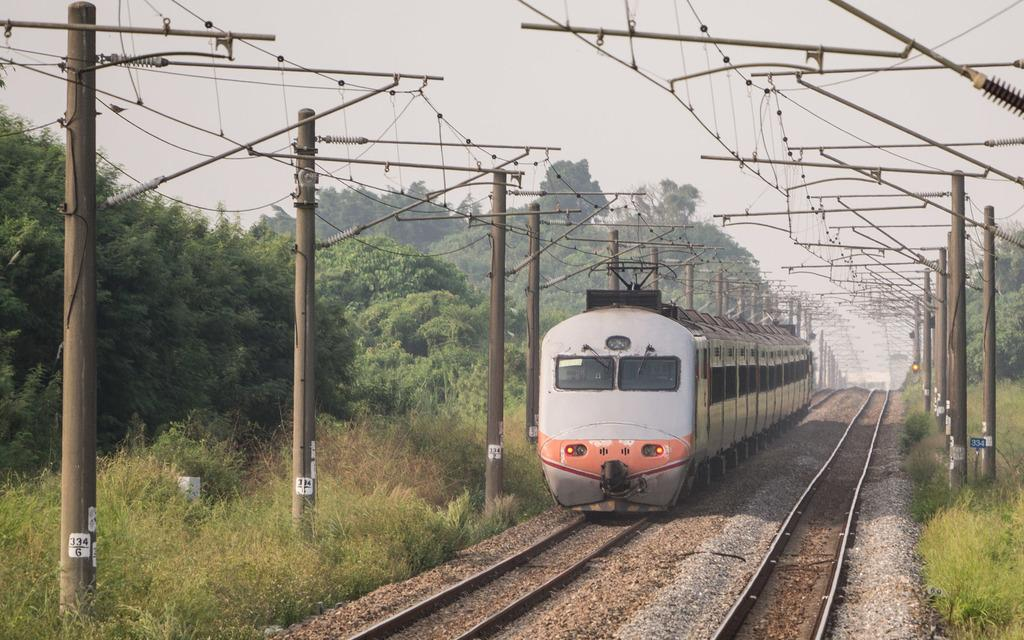What is the main subject of the image? There is a train in the image. Where is the train located? The train is on a railway track. What can be seen around the train? There are many poles around the train. What is visible behind the poles? There are a lot of trees behind the poles. How many oranges are hanging from the trees behind the poles? There are no oranges visible in the image; only trees can be seen behind the poles. 